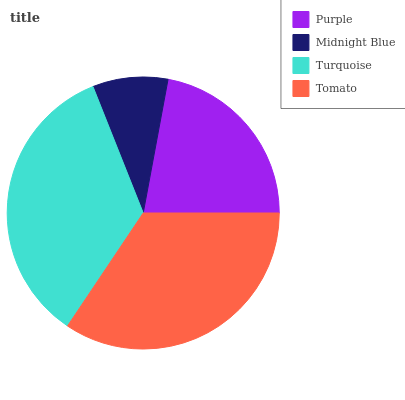Is Midnight Blue the minimum?
Answer yes or no. Yes. Is Turquoise the maximum?
Answer yes or no. Yes. Is Turquoise the minimum?
Answer yes or no. No. Is Midnight Blue the maximum?
Answer yes or no. No. Is Turquoise greater than Midnight Blue?
Answer yes or no. Yes. Is Midnight Blue less than Turquoise?
Answer yes or no. Yes. Is Midnight Blue greater than Turquoise?
Answer yes or no. No. Is Turquoise less than Midnight Blue?
Answer yes or no. No. Is Tomato the high median?
Answer yes or no. Yes. Is Purple the low median?
Answer yes or no. Yes. Is Midnight Blue the high median?
Answer yes or no. No. Is Turquoise the low median?
Answer yes or no. No. 